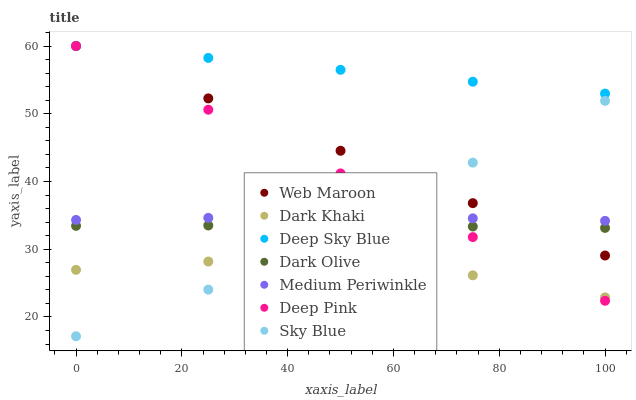Does Dark Khaki have the minimum area under the curve?
Answer yes or no. Yes. Does Deep Sky Blue have the maximum area under the curve?
Answer yes or no. Yes. Does Web Maroon have the minimum area under the curve?
Answer yes or no. No. Does Web Maroon have the maximum area under the curve?
Answer yes or no. No. Is Deep Pink the smoothest?
Answer yes or no. Yes. Is Sky Blue the roughest?
Answer yes or no. Yes. Is Web Maroon the smoothest?
Answer yes or no. No. Is Web Maroon the roughest?
Answer yes or no. No. Does Sky Blue have the lowest value?
Answer yes or no. Yes. Does Web Maroon have the lowest value?
Answer yes or no. No. Does Deep Sky Blue have the highest value?
Answer yes or no. Yes. Does Dark Olive have the highest value?
Answer yes or no. No. Is Dark Khaki less than Medium Periwinkle?
Answer yes or no. Yes. Is Deep Sky Blue greater than Dark Olive?
Answer yes or no. Yes. Does Sky Blue intersect Deep Pink?
Answer yes or no. Yes. Is Sky Blue less than Deep Pink?
Answer yes or no. No. Is Sky Blue greater than Deep Pink?
Answer yes or no. No. Does Dark Khaki intersect Medium Periwinkle?
Answer yes or no. No. 